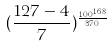<formula> <loc_0><loc_0><loc_500><loc_500>( \frac { 1 2 7 - 4 } { 7 } ) ^ { \frac { 1 0 0 ^ { 1 6 8 } } { 3 7 0 } }</formula> 